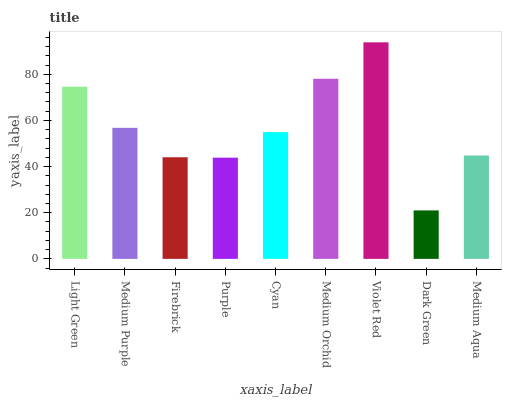Is Dark Green the minimum?
Answer yes or no. Yes. Is Violet Red the maximum?
Answer yes or no. Yes. Is Medium Purple the minimum?
Answer yes or no. No. Is Medium Purple the maximum?
Answer yes or no. No. Is Light Green greater than Medium Purple?
Answer yes or no. Yes. Is Medium Purple less than Light Green?
Answer yes or no. Yes. Is Medium Purple greater than Light Green?
Answer yes or no. No. Is Light Green less than Medium Purple?
Answer yes or no. No. Is Cyan the high median?
Answer yes or no. Yes. Is Cyan the low median?
Answer yes or no. Yes. Is Dark Green the high median?
Answer yes or no. No. Is Medium Orchid the low median?
Answer yes or no. No. 